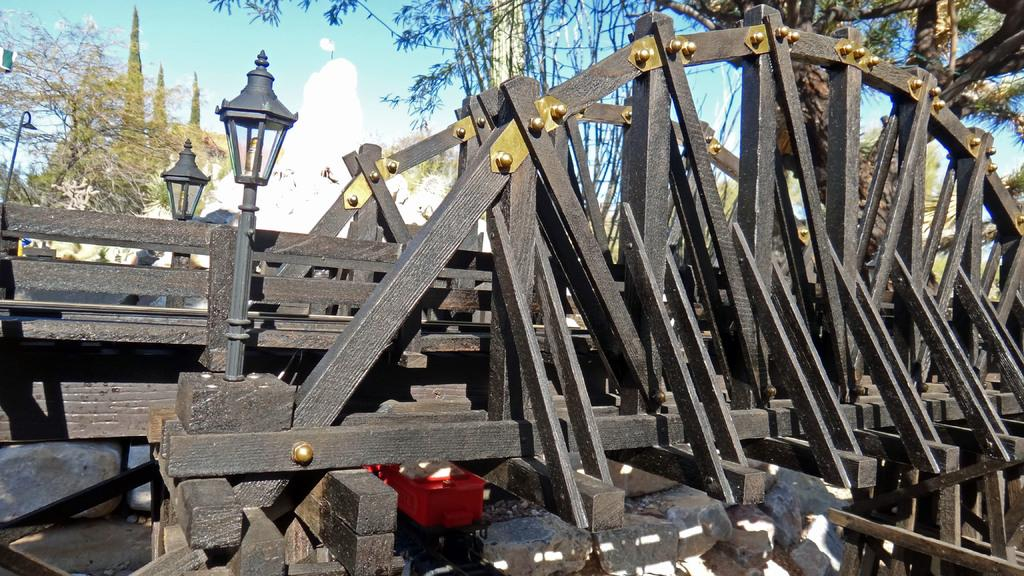What type of structure is present in the image? There is a wooden bridge in the image. Are there any additional features on the bridge? Yes, there are lights on the bridge. What can be seen in the background of the image? There are trees in the background of the image. What is visible at the top of the image? The sky is visible at the top of the image, and there are clouds in the sky. Can you hear the class of students crying in the image? There is no class or crying students present in the image; it features a wooden bridge with lights and a background of trees and clouds. 